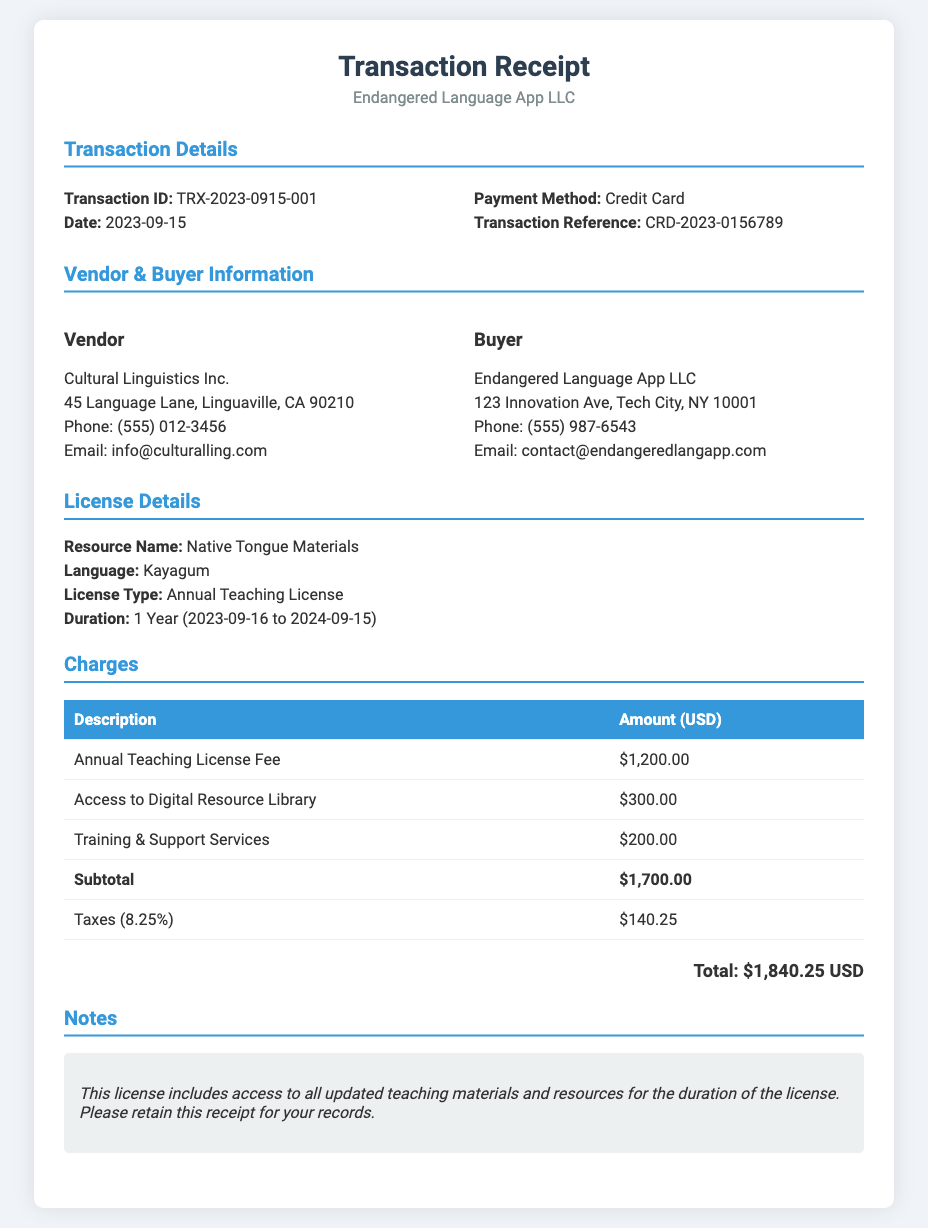What is the transaction ID? The transaction ID is specified in the transaction details section as a unique identifier for the transaction.
Answer: TRX-2023-0915-001 What is the payment method? The payment method used for the transaction is indicated in the transaction details section.
Answer: Credit Card What is the license type? The license type for the purchased resources is mentioned in the license details section of the document.
Answer: Annual Teaching License What is the subtotal amount? The subtotal is calculated before taxes and is listed in the charges section of the document.
Answer: $1,700.00 How much were the taxes? The document specifies the tax amount applied as part of the charges, which is calculated from the subtotal.
Answer: $140.25 What is the total amount paid? The total amount is the sum of the subtotal and taxes, presented at the end of the charges section.
Answer: $1,840.25 Who is the vendor? The vendor's information is provided in the vendor & buyer information section, listing the entity selling the resources.
Answer: Cultural Linguistics Inc What is the duration of the license? The duration of the license specifies the time period for which the license is valid, mentioned in the license details section.
Answer: 1 Year (2023-09-16 to 2024-09-15) What note accompanies the receipt? The note section provides additional information about the license and advises on record retention.
Answer: This license includes access to all updated teaching materials and resources for the duration of the license. Please retain this receipt for your records 